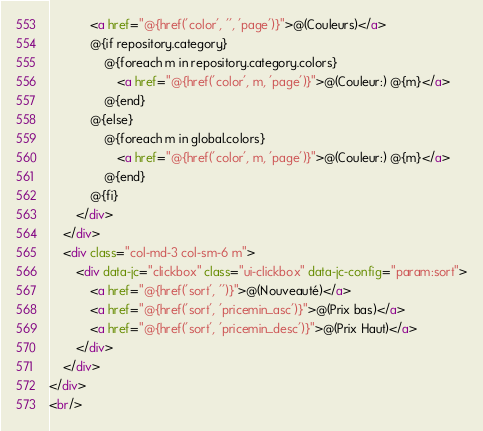<code> <loc_0><loc_0><loc_500><loc_500><_HTML_>			<a href="@{href('color', '', 'page')}">@(Couleurs)</a>
			@{if repository.category}
				@{foreach m in repository.category.colors}
					<a href="@{href('color', m, 'page')}">@(Couleur:) @{m}</a>
				@{end}
			@{else}
				@{foreach m in global.colors}
					<a href="@{href('color', m, 'page')}">@(Couleur:) @{m}</a>
				@{end}
			@{fi}
		</div>
	</div>
	<div class="col-md-3 col-sm-6 m">
		<div data-jc="clickbox" class="ui-clickbox" data-jc-config="param:sort">
			<a href="@{href('sort', '')}">@(Nouveauté)</a>
			<a href="@{href('sort', 'pricemin_asc')}">@(Prix bas)</a>
			<a href="@{href('sort', 'pricemin_desc')}">@(Prix Haut)</a>
		</div>
	</div>
</div>
<br/></code> 